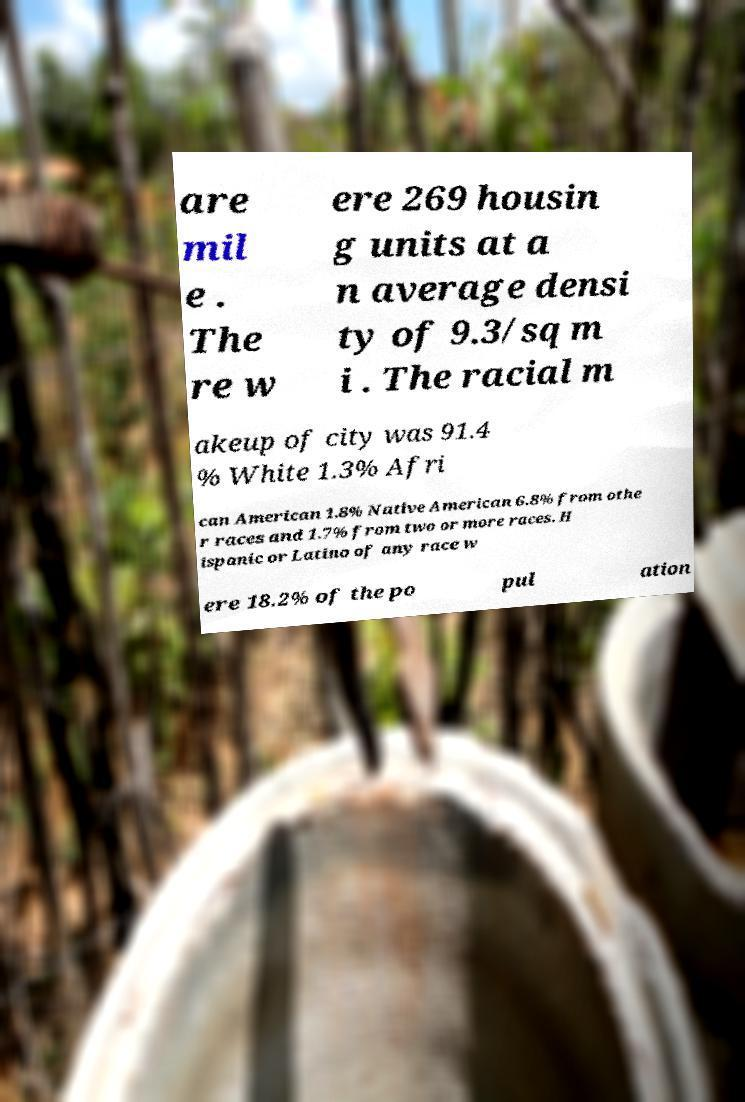I need the written content from this picture converted into text. Can you do that? are mil e . The re w ere 269 housin g units at a n average densi ty of 9.3/sq m i . The racial m akeup of city was 91.4 % White 1.3% Afri can American 1.8% Native American 6.8% from othe r races and 1.7% from two or more races. H ispanic or Latino of any race w ere 18.2% of the po pul ation 